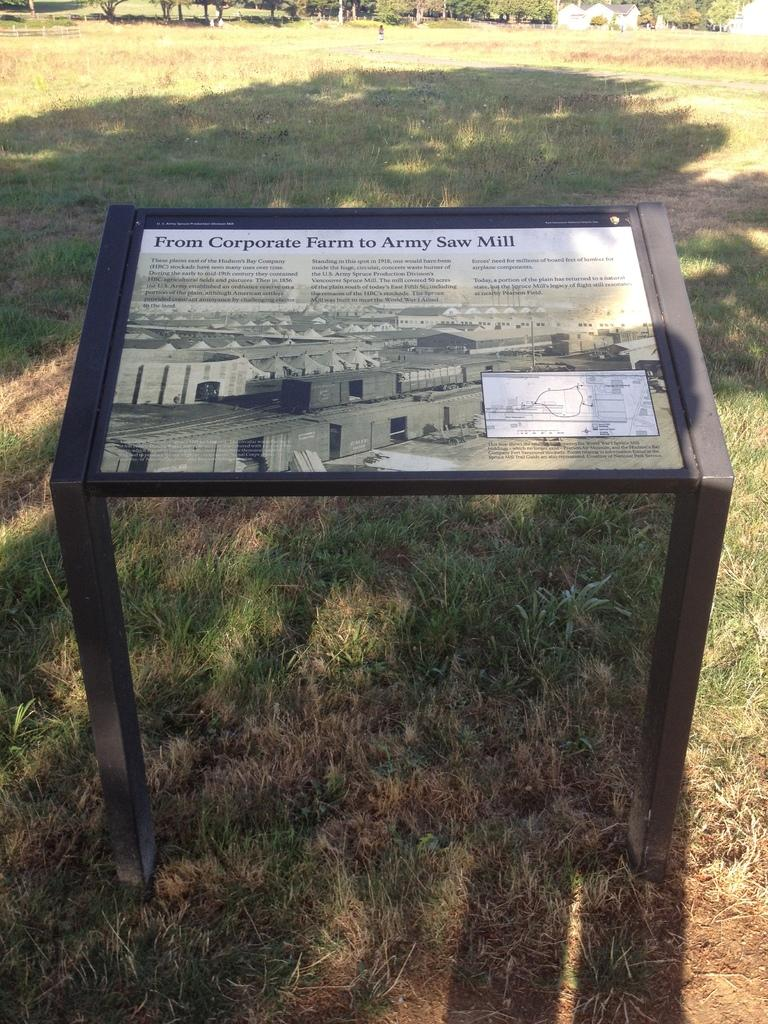What is attached to the two poles in the image? There is a hoarding attached to the two poles in the image. Where are the poles located? The poles are on the grass. What type of vegetation is present in the image? There is grass on the ground. What can be seen in the background of the image? There are buildings and trees in the background. Is there a cave visible in the image? No, there is no cave present in the image. 